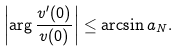Convert formula to latex. <formula><loc_0><loc_0><loc_500><loc_500>\left | \arg \frac { v ^ { \prime } ( 0 ) } { v ( 0 ) } \right | \leq \arcsin a _ { N } .</formula> 